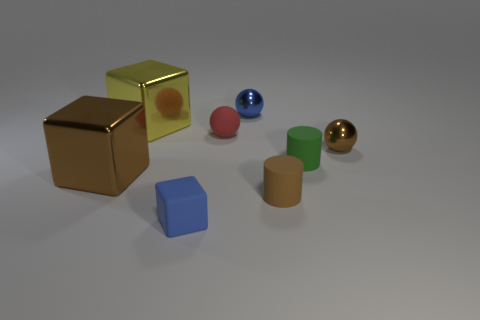The red object that is the same material as the tiny brown cylinder is what shape? The red object sharing the same material characteristics as the small brown cylinder is a sphere, exhibiting a perfectly round shape. 